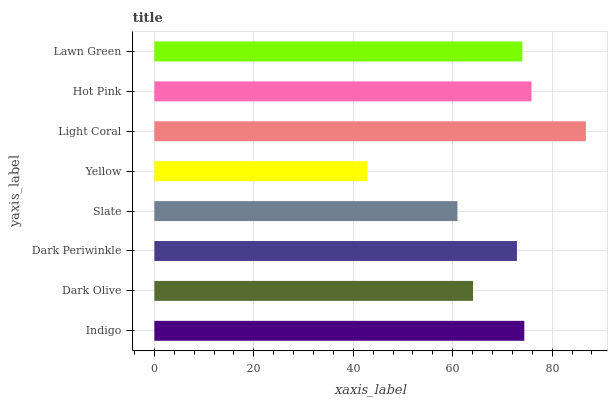Is Yellow the minimum?
Answer yes or no. Yes. Is Light Coral the maximum?
Answer yes or no. Yes. Is Dark Olive the minimum?
Answer yes or no. No. Is Dark Olive the maximum?
Answer yes or no. No. Is Indigo greater than Dark Olive?
Answer yes or no. Yes. Is Dark Olive less than Indigo?
Answer yes or no. Yes. Is Dark Olive greater than Indigo?
Answer yes or no. No. Is Indigo less than Dark Olive?
Answer yes or no. No. Is Lawn Green the high median?
Answer yes or no. Yes. Is Dark Periwinkle the low median?
Answer yes or no. Yes. Is Indigo the high median?
Answer yes or no. No. Is Lawn Green the low median?
Answer yes or no. No. 